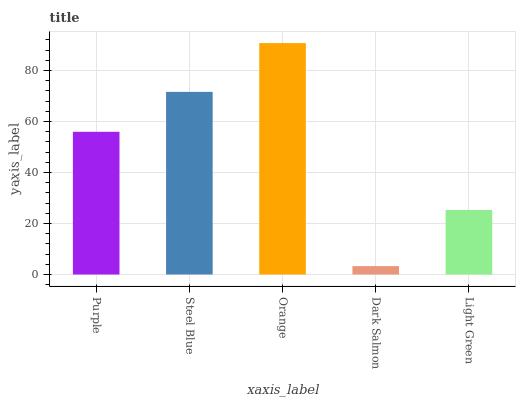Is Dark Salmon the minimum?
Answer yes or no. Yes. Is Orange the maximum?
Answer yes or no. Yes. Is Steel Blue the minimum?
Answer yes or no. No. Is Steel Blue the maximum?
Answer yes or no. No. Is Steel Blue greater than Purple?
Answer yes or no. Yes. Is Purple less than Steel Blue?
Answer yes or no. Yes. Is Purple greater than Steel Blue?
Answer yes or no. No. Is Steel Blue less than Purple?
Answer yes or no. No. Is Purple the high median?
Answer yes or no. Yes. Is Purple the low median?
Answer yes or no. Yes. Is Light Green the high median?
Answer yes or no. No. Is Light Green the low median?
Answer yes or no. No. 